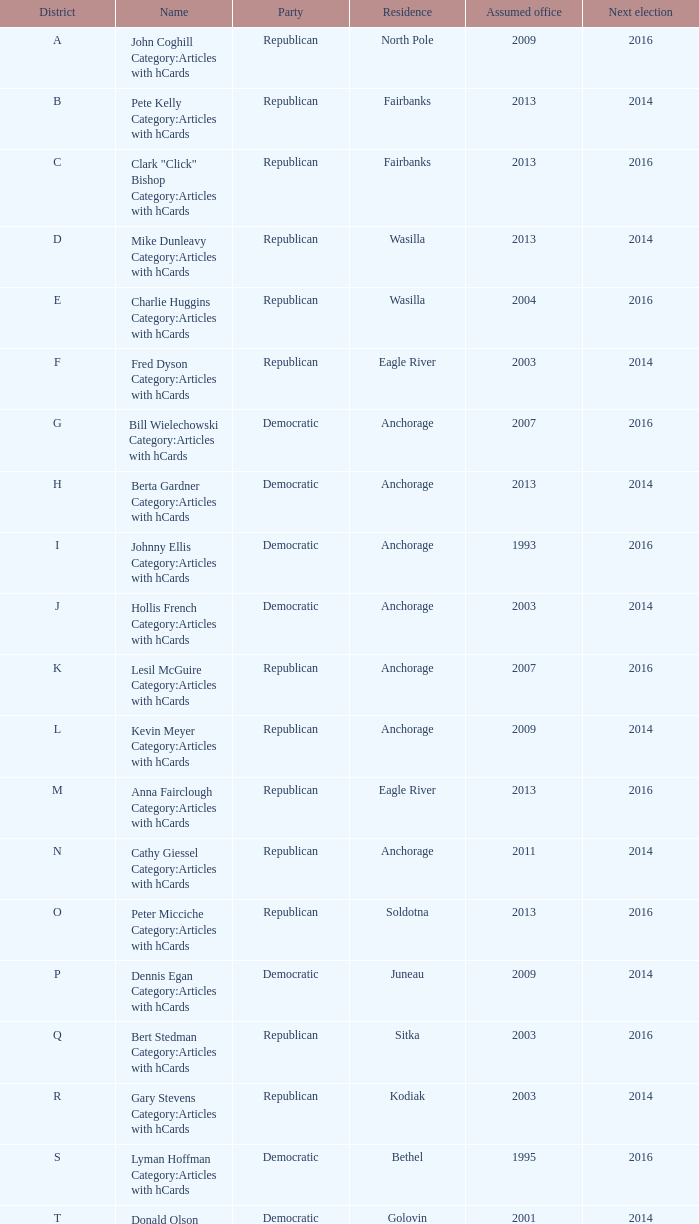In district a, the senator who started their term before 2013 and faces re-election after 2014 - which party are they a member of? Republican. 